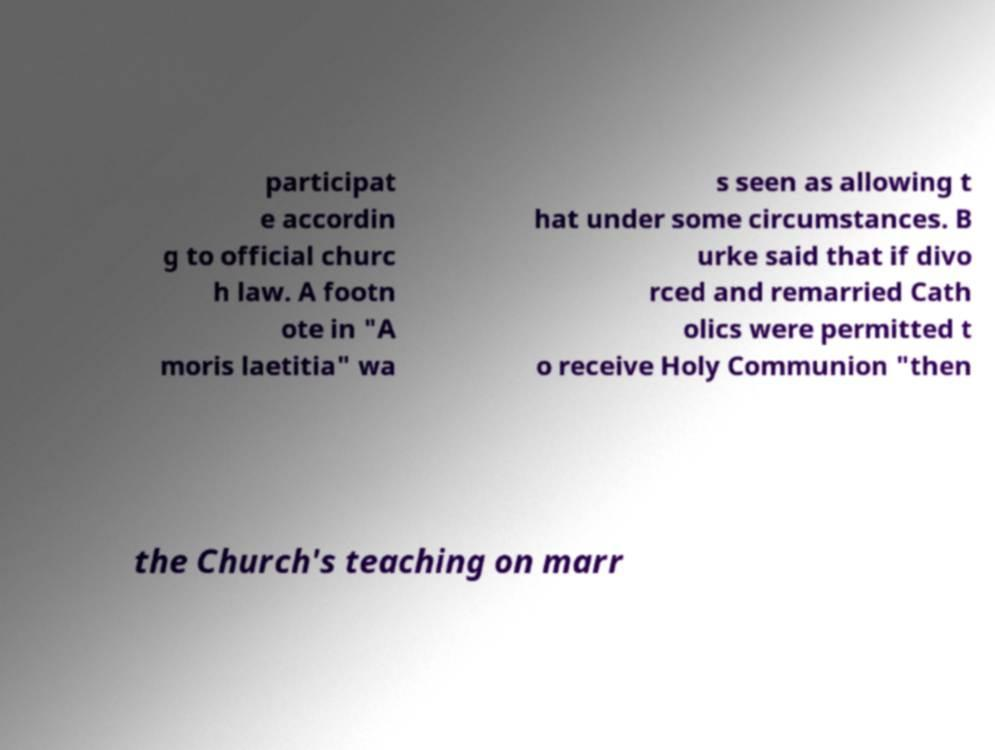There's text embedded in this image that I need extracted. Can you transcribe it verbatim? participat e accordin g to official churc h law. A footn ote in "A moris laetitia" wa s seen as allowing t hat under some circumstances. B urke said that if divo rced and remarried Cath olics were permitted t o receive Holy Communion "then the Church's teaching on marr 